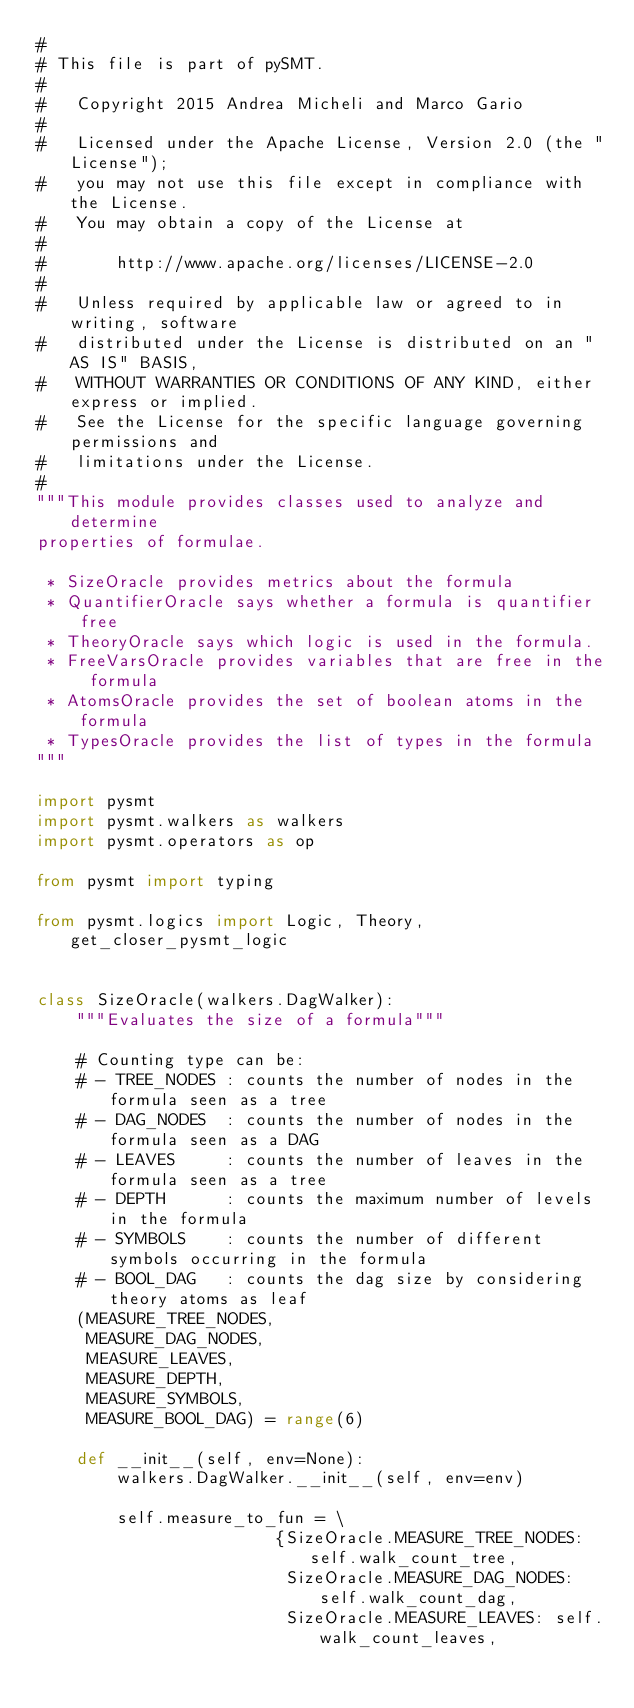Convert code to text. <code><loc_0><loc_0><loc_500><loc_500><_Python_>#
# This file is part of pySMT.
#
#   Copyright 2015 Andrea Micheli and Marco Gario
#
#   Licensed under the Apache License, Version 2.0 (the "License");
#   you may not use this file except in compliance with the License.
#   You may obtain a copy of the License at
#
#       http://www.apache.org/licenses/LICENSE-2.0
#
#   Unless required by applicable law or agreed to in writing, software
#   distributed under the License is distributed on an "AS IS" BASIS,
#   WITHOUT WARRANTIES OR CONDITIONS OF ANY KIND, either express or implied.
#   See the License for the specific language governing permissions and
#   limitations under the License.
#
"""This module provides classes used to analyze and determine
properties of formulae.

 * SizeOracle provides metrics about the formula
 * QuantifierOracle says whether a formula is quantifier free
 * TheoryOracle says which logic is used in the formula.
 * FreeVarsOracle provides variables that are free in the formula
 * AtomsOracle provides the set of boolean atoms in the formula
 * TypesOracle provides the list of types in the formula
"""

import pysmt
import pysmt.walkers as walkers
import pysmt.operators as op

from pysmt import typing

from pysmt.logics import Logic, Theory, get_closer_pysmt_logic


class SizeOracle(walkers.DagWalker):
    """Evaluates the size of a formula"""

    # Counting type can be:
    # - TREE_NODES : counts the number of nodes in the formula seen as a tree
    # - DAG_NODES  : counts the number of nodes in the formula seen as a DAG
    # - LEAVES     : counts the number of leaves in the formula seen as a tree
    # - DEPTH      : counts the maximum number of levels in the formula
    # - SYMBOLS    : counts the number of different symbols occurring in the formula
    # - BOOL_DAG   : counts the dag size by considering theory atoms as leaf
    (MEASURE_TREE_NODES,
     MEASURE_DAG_NODES,
     MEASURE_LEAVES,
     MEASURE_DEPTH,
     MEASURE_SYMBOLS,
     MEASURE_BOOL_DAG) = range(6)

    def __init__(self, env=None):
        walkers.DagWalker.__init__(self, env=env)

        self.measure_to_fun = \
                        {SizeOracle.MEASURE_TREE_NODES: self.walk_count_tree,
                         SizeOracle.MEASURE_DAG_NODES: self.walk_count_dag,
                         SizeOracle.MEASURE_LEAVES: self.walk_count_leaves,</code> 